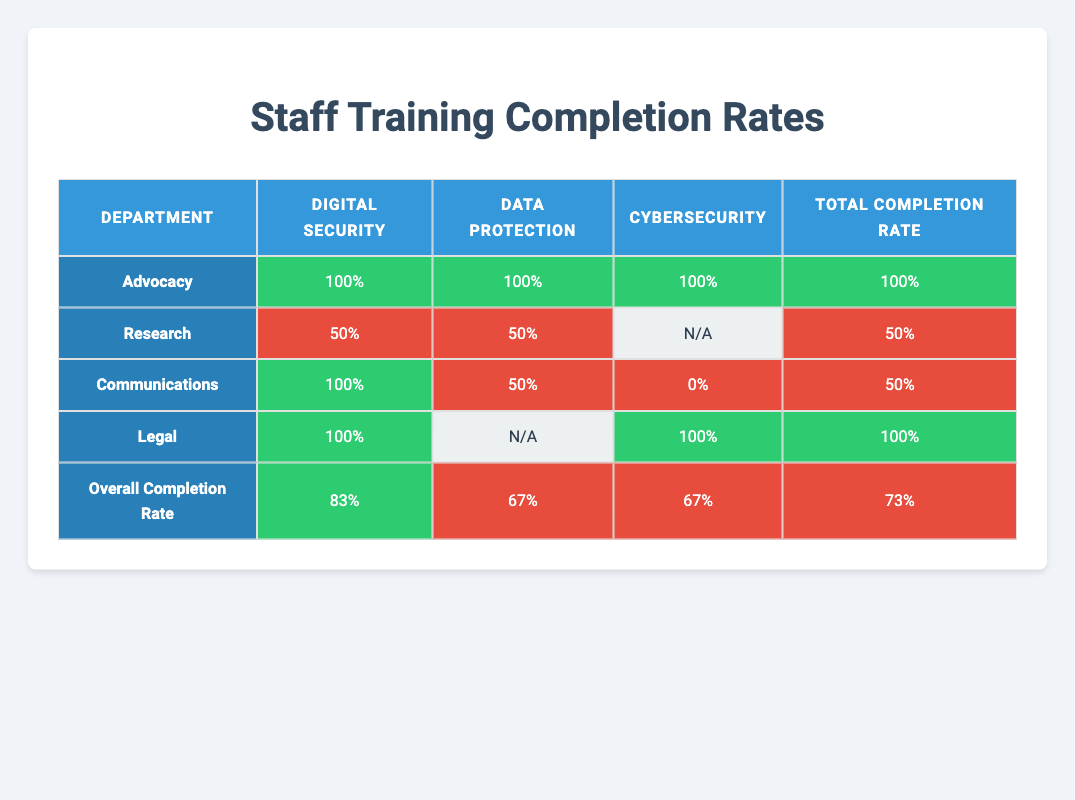What is the completion rate for Digital Security in the Advocacy department? The completion rate for Digital Security in the Advocacy department is given directly in the table as 100%.
Answer: 100% What is the overall completion rate for the Research department? The overall completion rate for the Research department, considering all course types, is listed under the "Total Completion Rate" column as 50%.
Answer: 50% Which department has the lowest completion rate for Data Protection? Looking at the Data Protection completion rates for each department, the Communications department has the lowest rate, which is 50%.
Answer: Communications Is the completion rate for Cybersecurity in the Legal department above or below 50%? The completion rate for Cybersecurity in the Legal department is 100%, which is above 50%.
Answer: Above How many departments have a completion rate of 100% for Digital Security? The departments with a completion rate of 100% for Digital Security are Advocacy, Legal, and Communications. Therefore, there are 3 departments with this completion rate.
Answer: 3 What is the difference between the Digital Security completion rate and the Total Completion Rate for the Advocacy department? The Digital Security completion rate for Advocacy is 100% and the Total Completion Rate is also 100%. The difference is 100% - 100% = 0%.
Answer: 0% Are there any departments that received N/A for Data Protection? According to the table, the Legal department is listed as N/A for Data Protection, indicating that no data is available.
Answer: Yes What is the average completion rate for Cybersecurity across all departments? The completion rates for Cybersecurity are 100%, 0%, and not applicable for Legal and Research departments, respectively. Calculating gives (100% + 0% + 100%) / 3 = 66.67%.
Answer: 66.67% Which department has the highest overall completion rate and what is that rate? The Advocacy and Legal departments both have 100% as their overall completion rates, which is the highest among all departments.
Answer: 100% 